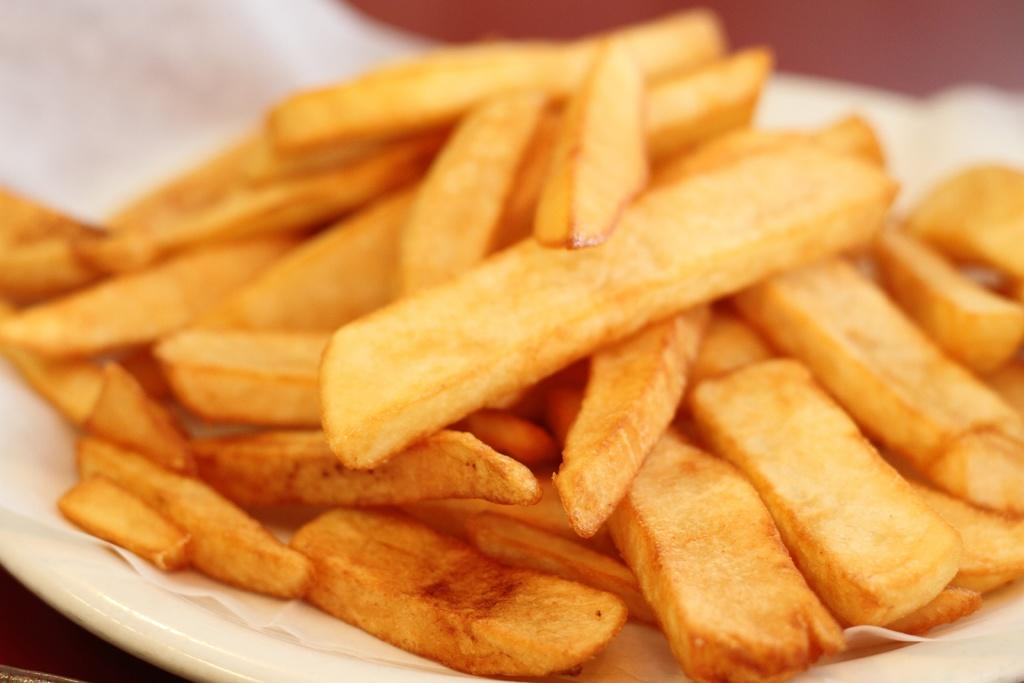What object is present on the plate in the image? There is a paper on the plate in the image. What is on the paper on the plate? The paper has fries on it. Can you describe the arrangement of the items on the plate? The plate has a paper on it, and the paper has fries on it. What type of soup is being served in the image? There is no soup present in the image; it features a plate with a paper and fries on it. 